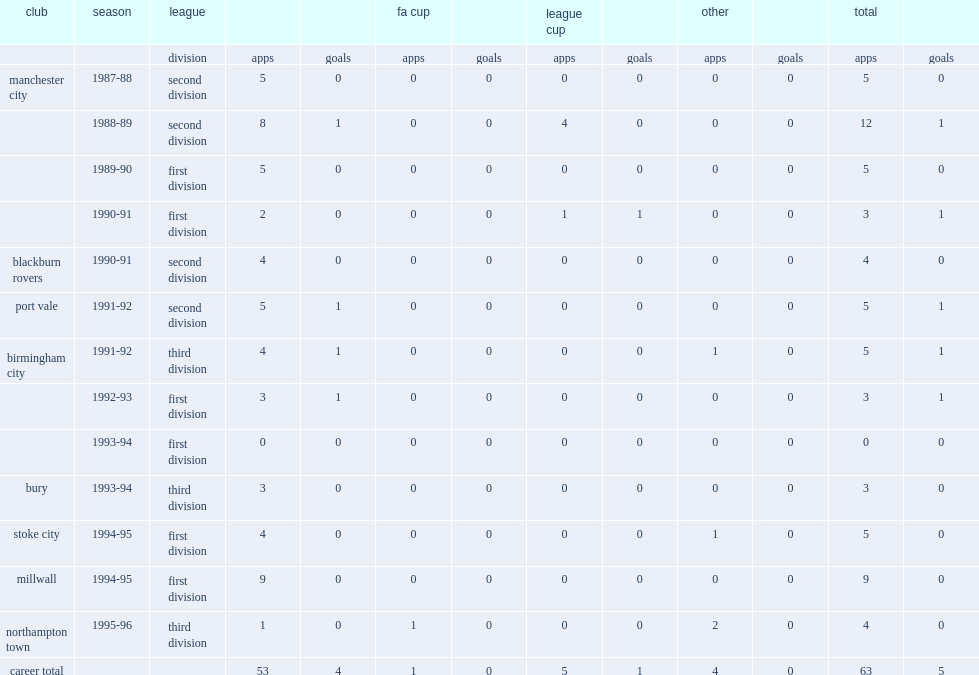How many games did jason beckford play for millwall in 1994-95? 9.0. 